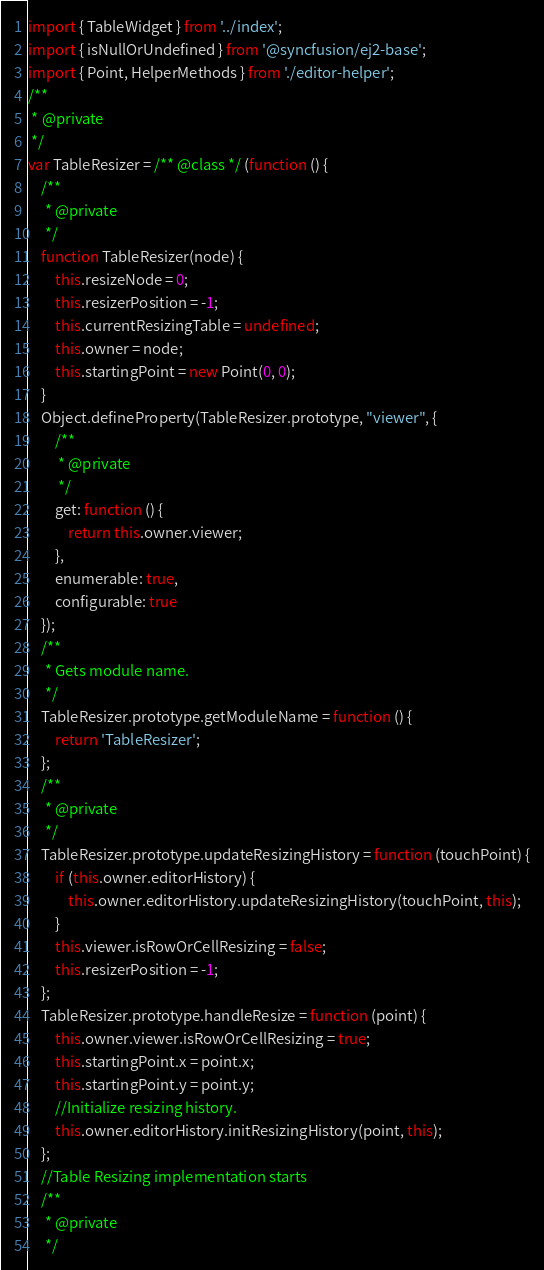Convert code to text. <code><loc_0><loc_0><loc_500><loc_500><_JavaScript_>import { TableWidget } from '../index';
import { isNullOrUndefined } from '@syncfusion/ej2-base';
import { Point, HelperMethods } from './editor-helper';
/**
 * @private
 */
var TableResizer = /** @class */ (function () {
    /**
     * @private
     */
    function TableResizer(node) {
        this.resizeNode = 0;
        this.resizerPosition = -1;
        this.currentResizingTable = undefined;
        this.owner = node;
        this.startingPoint = new Point(0, 0);
    }
    Object.defineProperty(TableResizer.prototype, "viewer", {
        /**
         * @private
         */
        get: function () {
            return this.owner.viewer;
        },
        enumerable: true,
        configurable: true
    });
    /**
     * Gets module name.
     */
    TableResizer.prototype.getModuleName = function () {
        return 'TableResizer';
    };
    /**
     * @private
     */
    TableResizer.prototype.updateResizingHistory = function (touchPoint) {
        if (this.owner.editorHistory) {
            this.owner.editorHistory.updateResizingHistory(touchPoint, this);
        }
        this.viewer.isRowOrCellResizing = false;
        this.resizerPosition = -1;
    };
    TableResizer.prototype.handleResize = function (point) {
        this.owner.viewer.isRowOrCellResizing = true;
        this.startingPoint.x = point.x;
        this.startingPoint.y = point.y;
        //Initialize resizing history.
        this.owner.editorHistory.initResizingHistory(point, this);
    };
    //Table Resizing implementation starts
    /**
     * @private
     */</code> 